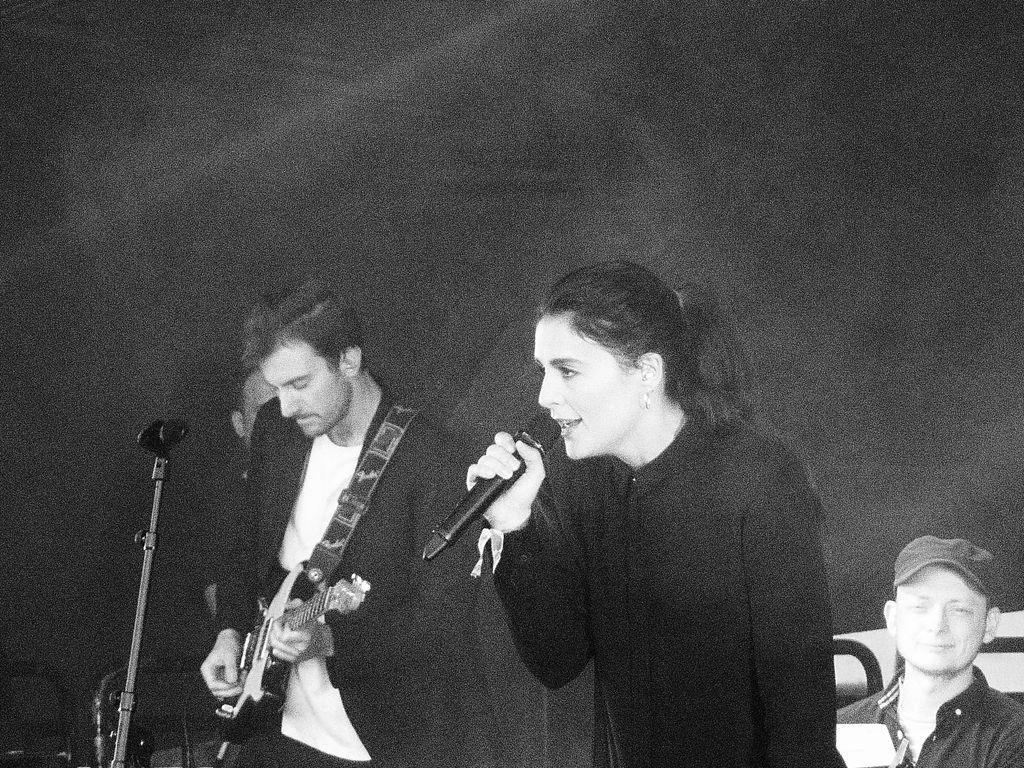Please provide a concise description of this image. In this image I can see few people where one is holding a guitar and one is holding a mic. I can also see one of them is wearing a cap. 